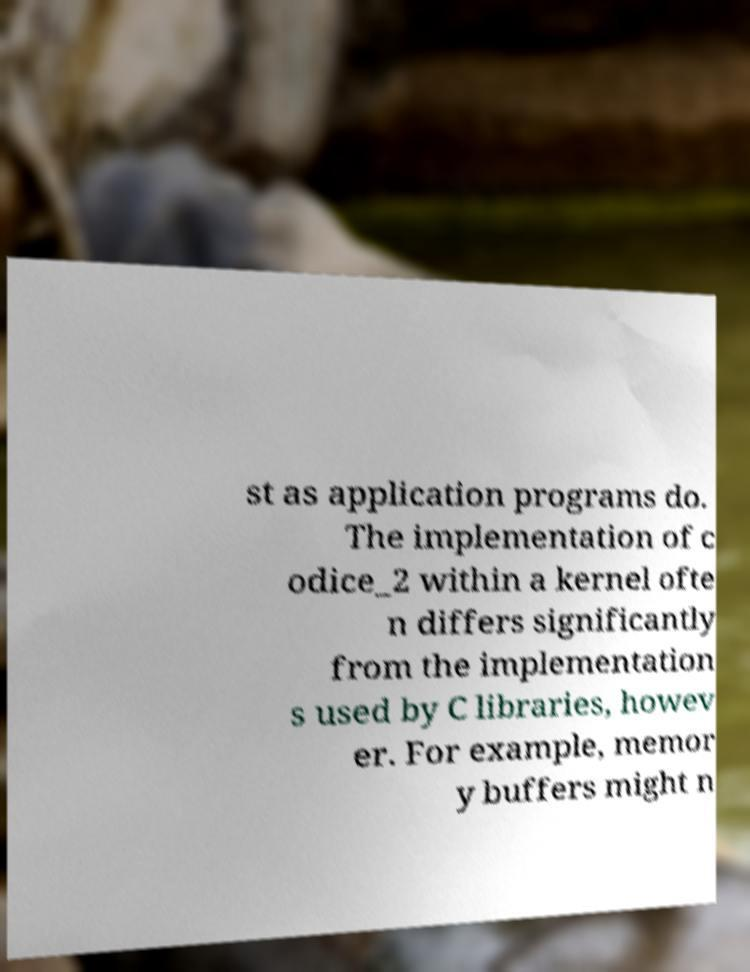For documentation purposes, I need the text within this image transcribed. Could you provide that? st as application programs do. The implementation of c odice_2 within a kernel ofte n differs significantly from the implementation s used by C libraries, howev er. For example, memor y buffers might n 